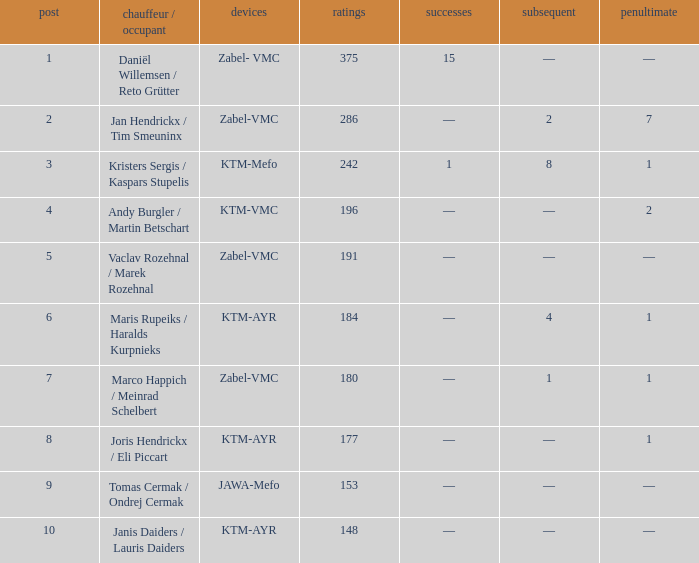Who occupied the driver/passenger seat when the position was below 8, the third was 1, and there was a single victory? Kristers Sergis / Kaspars Stupelis. 